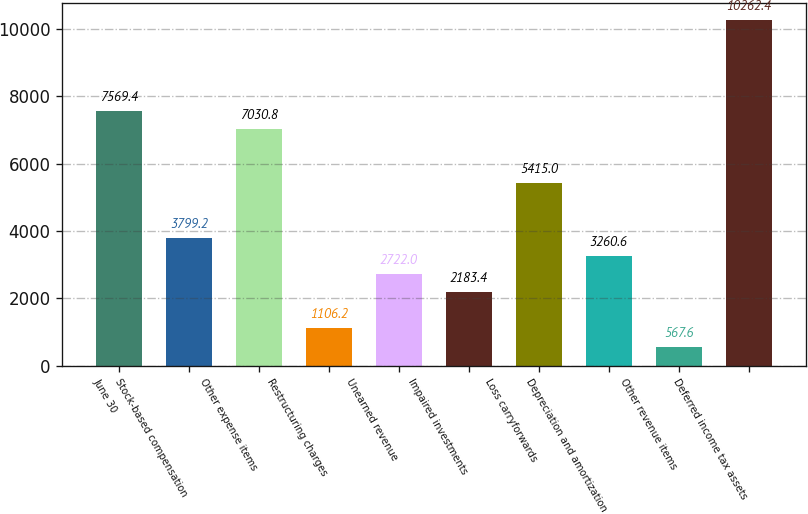Convert chart. <chart><loc_0><loc_0><loc_500><loc_500><bar_chart><fcel>June 30<fcel>Stock-based compensation<fcel>Other expense items<fcel>Restructuring charges<fcel>Unearned revenue<fcel>Impaired investments<fcel>Loss carryforwards<fcel>Depreciation and amortization<fcel>Other revenue items<fcel>Deferred income tax assets<nl><fcel>7569.4<fcel>3799.2<fcel>7030.8<fcel>1106.2<fcel>2722<fcel>2183.4<fcel>5415<fcel>3260.6<fcel>567.6<fcel>10262.4<nl></chart> 